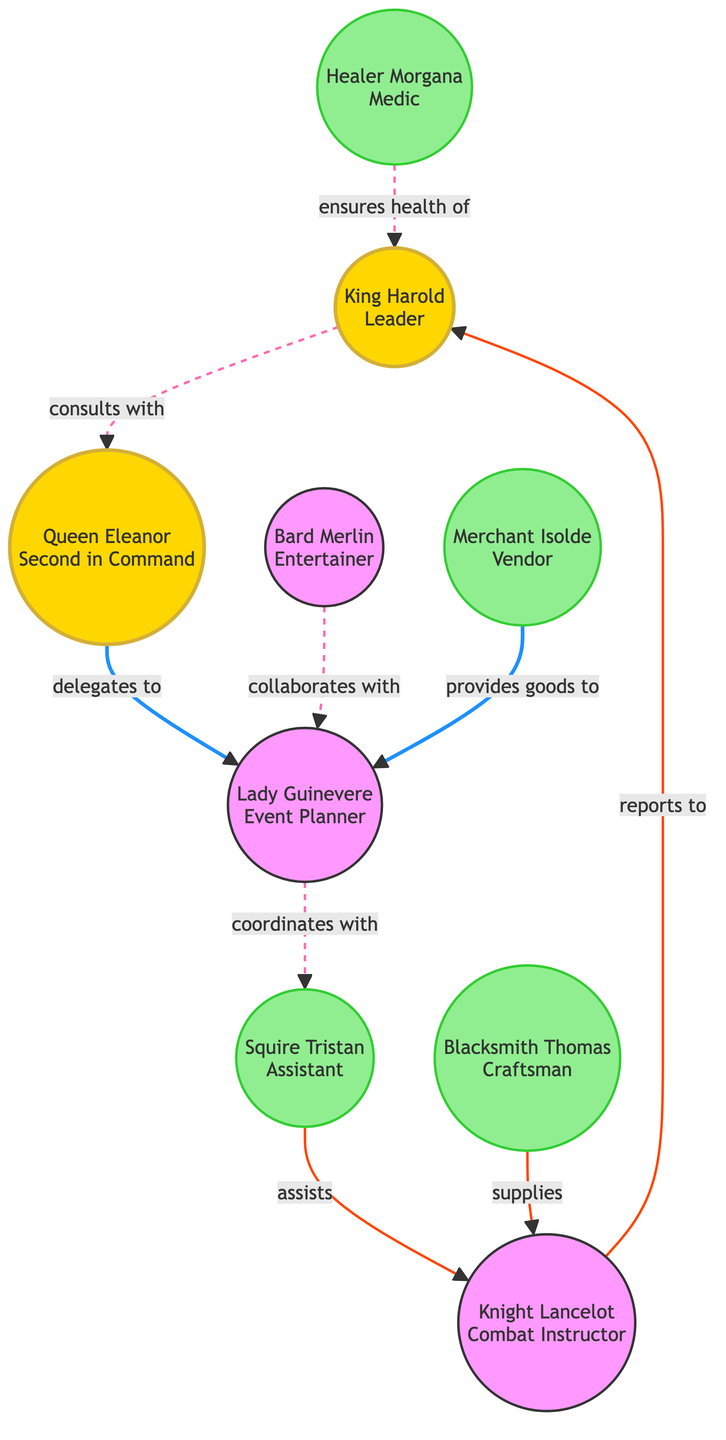What is the total number of nodes in the communication network? The diagram includes a list of participants in the Medieval Reenactment Society, which are categorized as nodes. By counting each participant listed in the nodes, we find there are 9 nodes in total.
Answer: 9 Who does Queen Eleanor delegate to? The connection from Queen Eleanor shows that she delegates tasks to Lady Guinevere, as indicated by the "delegates to" relationship in the diagram.
Answer: Lady Guinevere What role does Knight Lancelot have in the society? The label associated with Knight Lancelot identifies him as the Combat Instructor, which defines his primary function within the organization.
Answer: Combat Instructor Who collaborates with Lady Guinevere? The edge between Bard Merlin and Lady Guinevere explicitly states a collaboration. Therefore, Bard Merlin is identified as the individual who collaborates with her.
Answer: Bard Merlin Identify the role of Blacksmith Thomas. The information presented in the nodes describes Blacksmith Thomas as a craftsman, specifically indicating his responsibility in creating weapons and armor for the reenactment society.
Answer: Craftsman How many relationships does Knight Lancelot have in the diagram? Observing the edges connected to Knight Lancelot reveals that he has two distinct relationships: one reporting to King Harold and another involving assistance from Squire Tristan.
Answer: 2 Which node is the medic in the network? Healer Morgana is specifically designated as the medic according to the role stated in the nodes, indicating her responsibility in providing medical support.
Answer: Healer Morgana Which character ensures the health of King Harold? The relationship identified in the diagram indicates that Healer Morgana ensures the health of King Harold, establishing her role in health matters for the leader.
Answer: Healer Morgana How is Squire Tristan connected to Knight Lancelot? The edge shows a direct assist relationship from Squire Tristan to Knight Lancelot, indicating that Squire Tristan directly assists Knight Lancelot in his combat training efforts.
Answer: Assists 